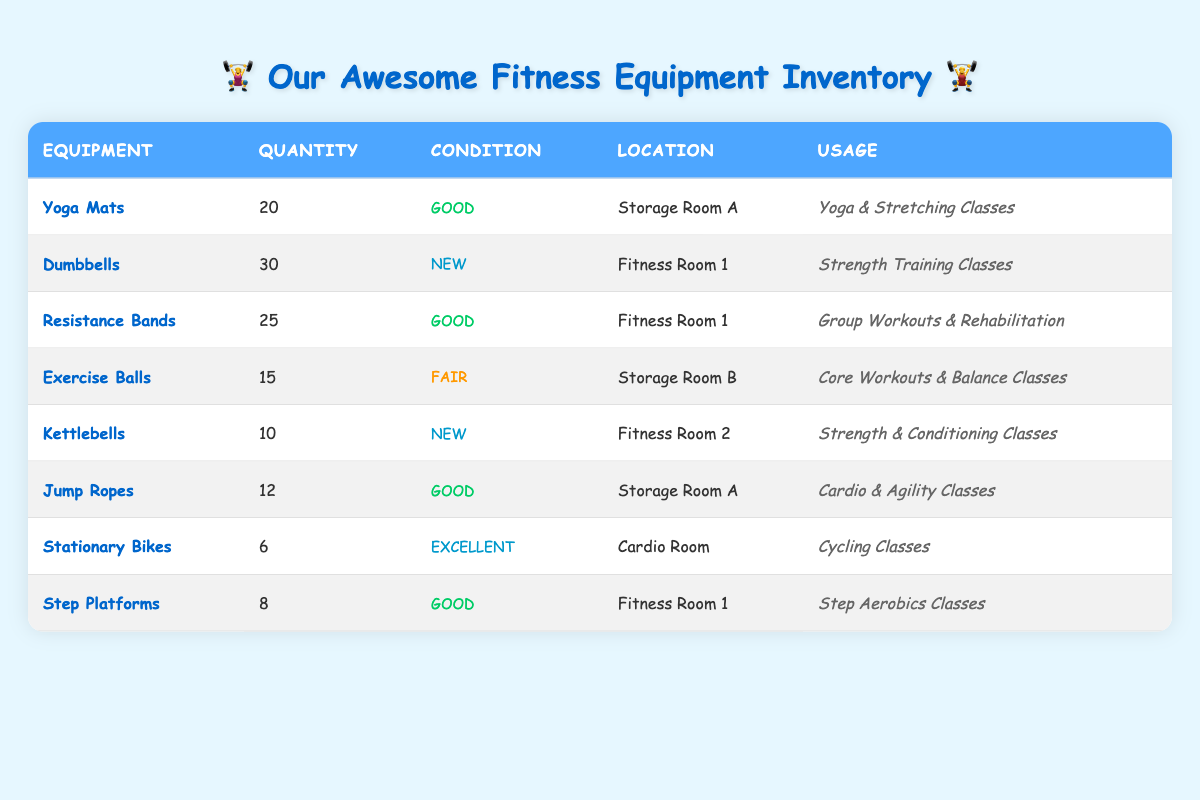What is the total quantity of Yoga Mats available? The amount of Yoga Mats listed in the table is 20.
Answer: 20 How many pieces of fitness equipment are in 'New' condition? There are two types of equipment in 'New' condition: Dumbbells (30) and Kettlebells (10). Therefore, the total quantity is 30 + 10 = 40.
Answer: 40 Where can you find the Exercise Balls? The Exercise Balls are located in Storage Room B as stated in the equipment's location column.
Answer: Storage Room B Is the condition of Jump Ropes classified as 'Excellent'? The condition of Jump Ropes is classified as 'Good,' not 'Excellent,' based on the data provided.
Answer: No What is the average quantity of fitness equipment per type listed in the table? To find the average, we sum all quantities: 20 + 30 + 25 + 15 + 10 + 12 + 6 + 8 = 126. There are 8 types of equipment, thus average = 126 ÷ 8 = 15.75.
Answer: 15.75 How many more Resistance Bands are there compared to Kettlebells? There are 25 Resistance Bands and 10 Kettlebells. The difference is 25 - 10 = 15.
Answer: 15 Is there any equipment available that can be used for both 'Yoga & Stretching Classes' and 'Core Workouts & Balance Classes'? The Yoga Mats are used for Yoga & Stretching Classes, and the Exercise Balls are used for Core Workouts & Balance Classes. There is no overlapping mentioned for these two specific usages.
Answer: No What percentage of the total equipment quantity is represented by the Stationary Bikes? The Stationary Bikes quantity is 6. Total equipment is 126, so the percentage is (6 ÷ 126) × 100 = 4.76%.
Answer: 4.76% 